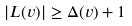Convert formula to latex. <formula><loc_0><loc_0><loc_500><loc_500>| L ( v ) | \geq \Delta ( v ) + 1</formula> 